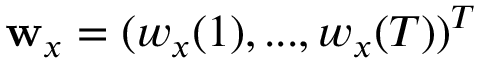<formula> <loc_0><loc_0><loc_500><loc_500>\mathbf w _ { x } = ( w _ { x } ( 1 ) , \dots , w _ { x } ( T ) ) ^ { T }</formula> 